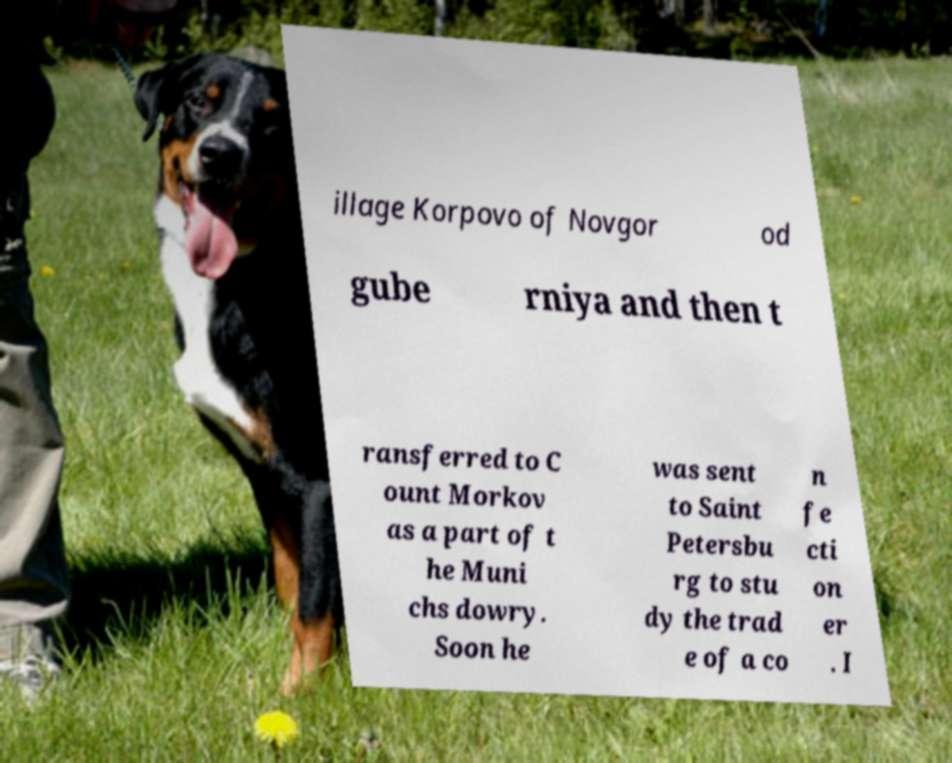Could you assist in decoding the text presented in this image and type it out clearly? illage Korpovo of Novgor od gube rniya and then t ransferred to C ount Morkov as a part of t he Muni chs dowry. Soon he was sent to Saint Petersbu rg to stu dy the trad e of a co n fe cti on er . I 